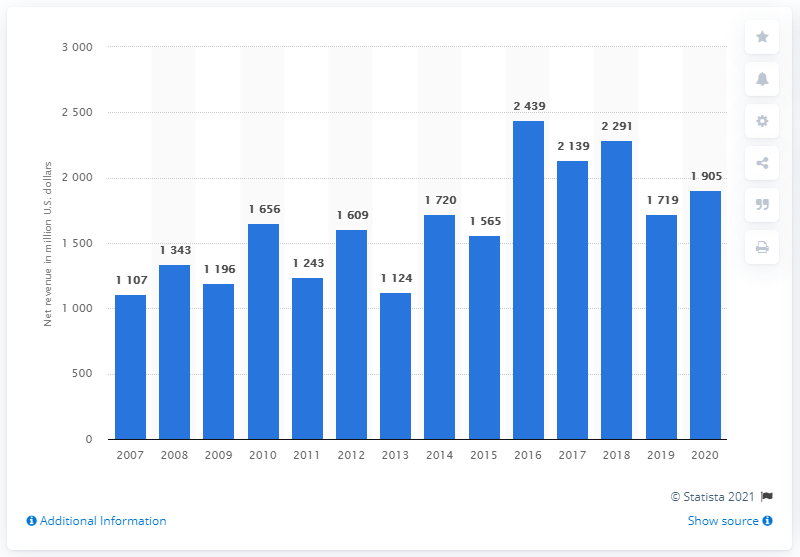Indicate a few pertinent items in this graphic. Blizzard Entertainment's net revenues in 2020 were approximately $190.5 million. 